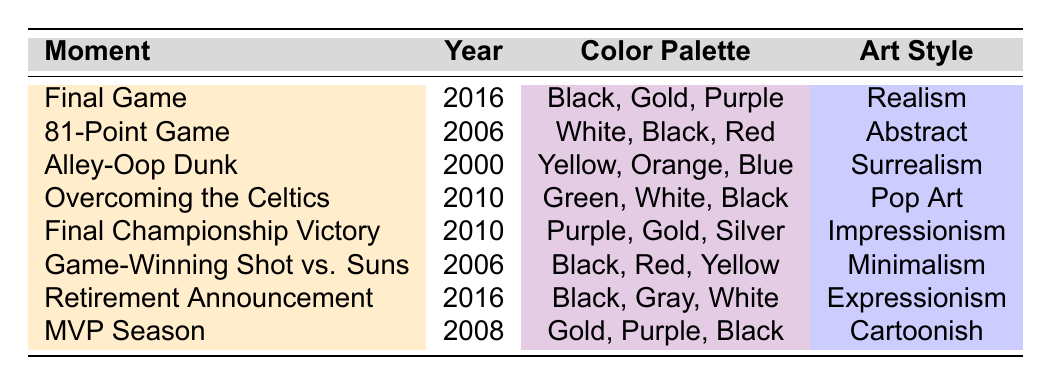What color palette is used in the 'Alley-Oop Dunk' moment? In the table, under the 'Color Palette' column for the 'Alley-Oop Dunk' moment, the colors listed are Yellow, Orange, and Blue.
Answer: Yellow, Orange, Blue Which moment has a dominant emotion of 'Tension'? Looking at the 'Dominant Emotion' column, the 'Game-Winning Shot vs. Suns' moment is associated with the emotion of 'Tension'.
Answer: Game-Winning Shot vs. Suns What art style is used for the 'Final Championship Victory'? The table shows that the 'Final Championship Victory' moment corresponds to the art style 'Impressionism'.
Answer: Impressionism How many moments feature the color 'Black' in their color palette? By counting the entries in the 'Color Palette' column, 'Black' appears in the following moments: 'Final Game', '81-Point Game', 'Game-Winning Shot vs. Suns', 'Overcoming the Celtics', and 'Retirement Announcement'. This totals to 5 moments.
Answer: 5 Which moment's art style is 'Realism'? From the table, the 'Final Game' is categorized under the art style 'Realism'.
Answer: Final Game Is there any moment that predominantly uses the color 'Green'? Looking at the 'Color Palette' column, only the 'Overcoming the Celtics' moment includes the color 'Green'. Therefore, the answer is yes.
Answer: Yes What is the average year of the moments listed in the table? Summing the years (2016, 2006, 2000, 2010, 2010, 2006, 2016, 2008), we get a total of 2016 + 2006 + 2000 + 2010 + 2010 + 2006 + 2016 + 2008 = 16072. There are 8 moments, so the average is 16072/8 = 2009.
Answer: 2009 Which moment has both 'Gold' and 'Purple' in its color palette? The moments 'Final Game' and 'MVP Season' both feature 'Gold' and 'Purple' in their color palettes.
Answer: Final Game, MVP Season What is the dominant emotion associated with the moment 'MVP Season'? The 'Dominant Emotion' column indicates that the 'MVP Season' moment evokes the emotion of 'Pride'.
Answer: Pride Which two moments have 'Gold' in their color palette, and how are their dominant emotions different? 'Final Championship Victory' and 'MVP Season' both have 'Gold' in their color palettes. 'Final Championship Victory' has the dominant emotion of 'Euphoria', while 'MVP Season' has 'Pride'.
Answer: Final Championship Victory (Euphoria), MVP Season (Pride) 